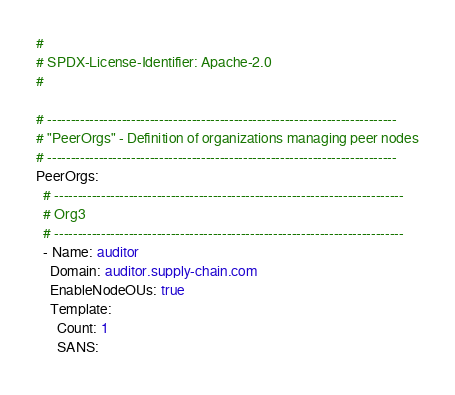Convert code to text. <code><loc_0><loc_0><loc_500><loc_500><_YAML_>#
# SPDX-License-Identifier: Apache-2.0
#

# ---------------------------------------------------------------------------
# "PeerOrgs" - Definition of organizations managing peer nodes
# ---------------------------------------------------------------------------
PeerOrgs:
  # ---------------------------------------------------------------------------
  # Org3
  # ---------------------------------------------------------------------------
  - Name: auditor
    Domain: auditor.supply-chain.com
    EnableNodeOUs: true
    Template:
      Count: 1
      SANS:</code> 